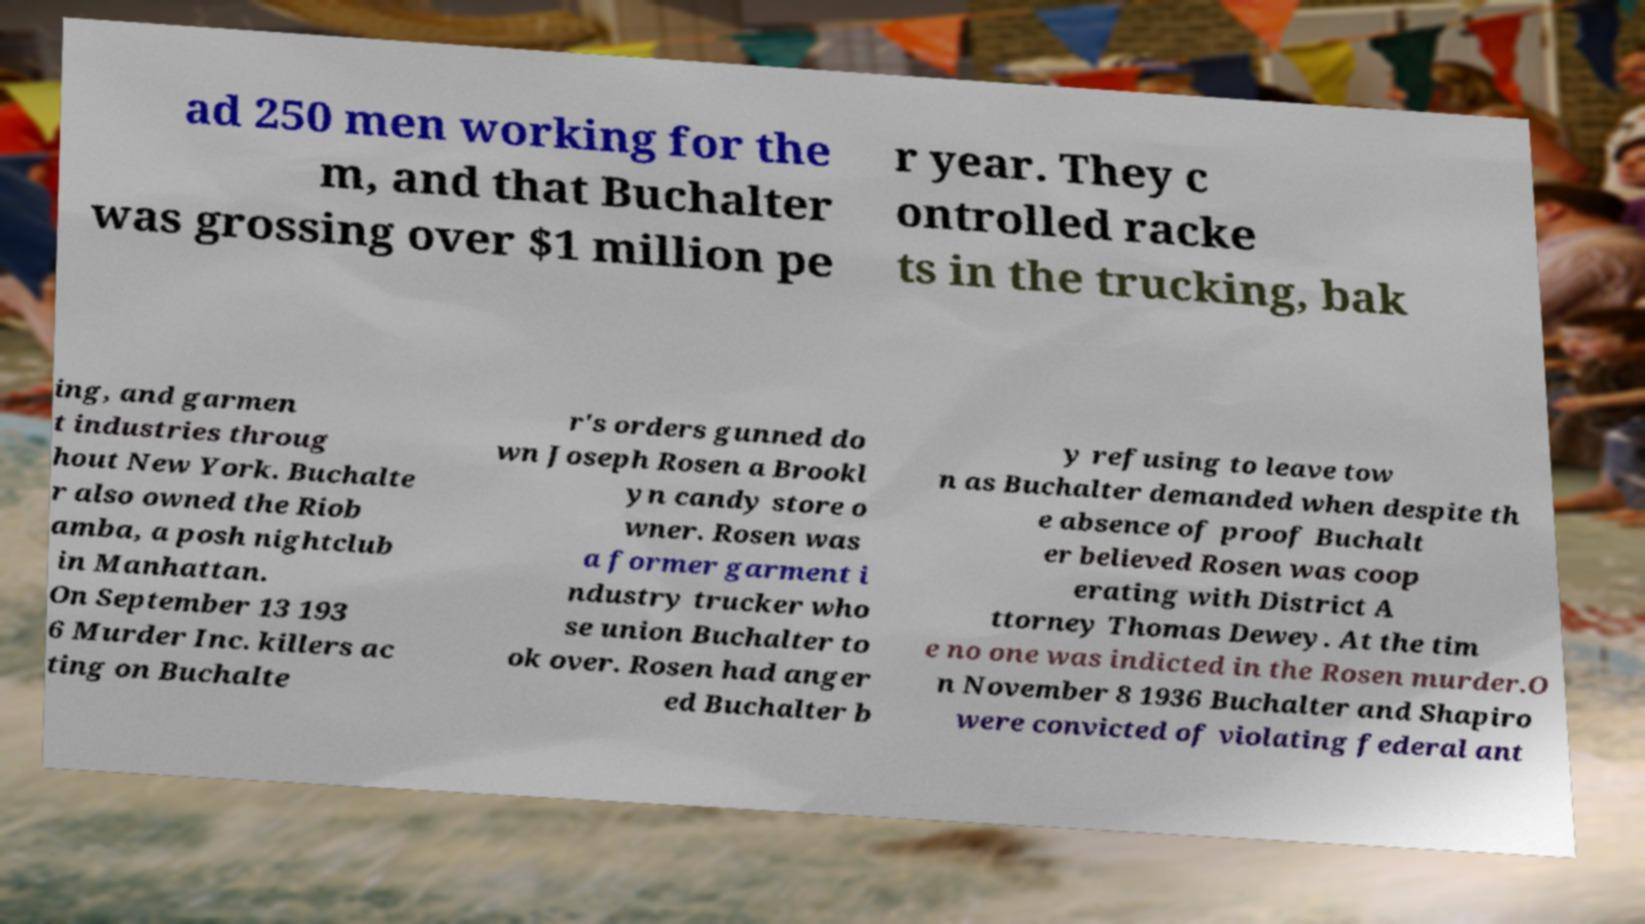Can you accurately transcribe the text from the provided image for me? ad 250 men working for the m, and that Buchalter was grossing over $1 million pe r year. They c ontrolled racke ts in the trucking, bak ing, and garmen t industries throug hout New York. Buchalte r also owned the Riob amba, a posh nightclub in Manhattan. On September 13 193 6 Murder Inc. killers ac ting on Buchalte r's orders gunned do wn Joseph Rosen a Brookl yn candy store o wner. Rosen was a former garment i ndustry trucker who se union Buchalter to ok over. Rosen had anger ed Buchalter b y refusing to leave tow n as Buchalter demanded when despite th e absence of proof Buchalt er believed Rosen was coop erating with District A ttorney Thomas Dewey. At the tim e no one was indicted in the Rosen murder.O n November 8 1936 Buchalter and Shapiro were convicted of violating federal ant 